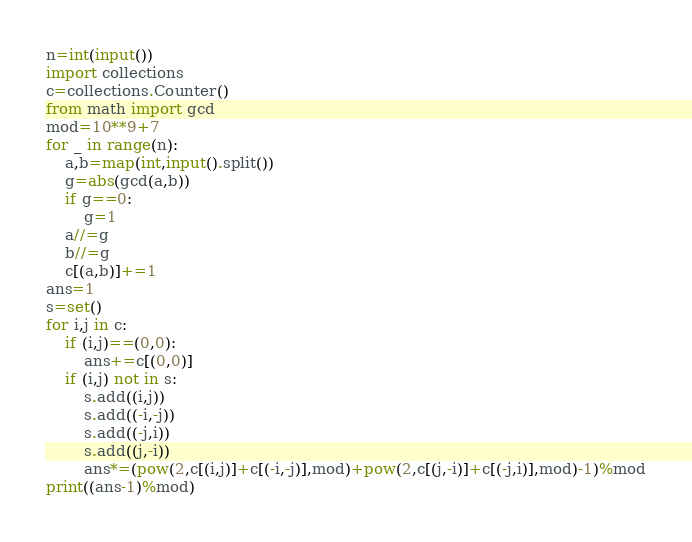<code> <loc_0><loc_0><loc_500><loc_500><_Python_>n=int(input())
import collections
c=collections.Counter()
from math import gcd
mod=10**9+7
for _ in range(n):
    a,b=map(int,input().split())
    g=abs(gcd(a,b))
    if g==0:
        g=1
    a//=g
    b//=g
    c[(a,b)]+=1
ans=1
s=set()
for i,j in c:
    if (i,j)==(0,0):
        ans+=c[(0,0)]
    if (i,j) not in s:
        s.add((i,j))
        s.add((-i,-j))
        s.add((-j,i))
        s.add((j,-i))
        ans*=(pow(2,c[(i,j)]+c[(-i,-j)],mod)+pow(2,c[(j,-i)]+c[(-j,i)],mod)-1)%mod
print((ans-1)%mod)</code> 